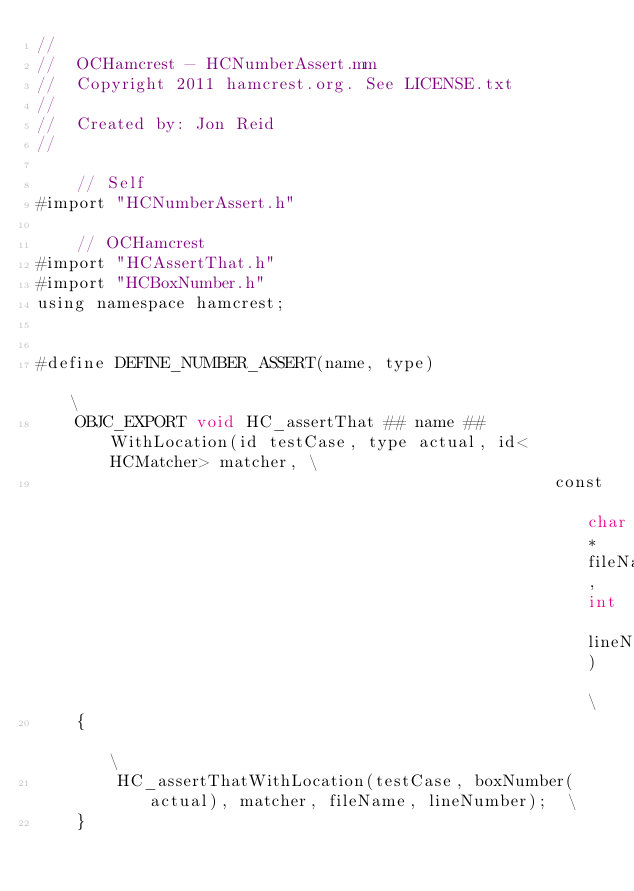<code> <loc_0><loc_0><loc_500><loc_500><_ObjectiveC_>//
//  OCHamcrest - HCNumberAssert.mm
//  Copyright 2011 hamcrest.org. See LICENSE.txt
//
//  Created by: Jon Reid
//

    // Self
#import "HCNumberAssert.h"

    // OCHamcrest
#import "HCAssertThat.h"
#import "HCBoxNumber.h"
using namespace hamcrest;


#define DEFINE_NUMBER_ASSERT(name, type)                                                        \
    OBJC_EXPORT void HC_assertThat ## name ## WithLocation(id testCase, type actual, id<HCMatcher> matcher, \
                                                    const char* fileName, int lineNumber)       \
    {                                                                                           \
        HC_assertThatWithLocation(testCase, boxNumber(actual), matcher, fileName, lineNumber);  \
    }
</code> 